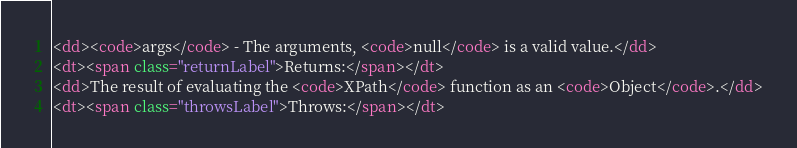Convert code to text. <code><loc_0><loc_0><loc_500><loc_500><_HTML_><dd><code>args</code> - The arguments, <code>null</code> is a valid value.</dd>
<dt><span class="returnLabel">Returns:</span></dt>
<dd>The result of evaluating the <code>XPath</code> function as an <code>Object</code>.</dd>
<dt><span class="throwsLabel">Throws:</span></dt></code> 